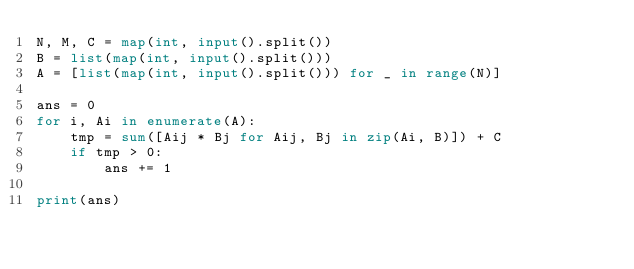<code> <loc_0><loc_0><loc_500><loc_500><_Python_>N, M, C = map(int, input().split())
B = list(map(int, input().split()))
A = [list(map(int, input().split())) for _ in range(N)]

ans = 0
for i, Ai in enumerate(A):
    tmp = sum([Aij * Bj for Aij, Bj in zip(Ai, B)]) + C
    if tmp > 0:
        ans += 1

print(ans)</code> 